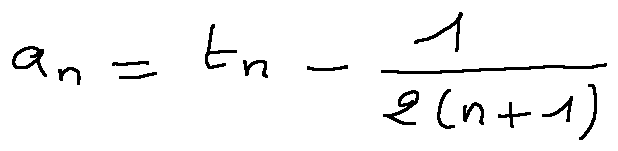<formula> <loc_0><loc_0><loc_500><loc_500>a _ { n } = t _ { n } - \frac { 1 } { 2 ( n + 1 ) }</formula> 